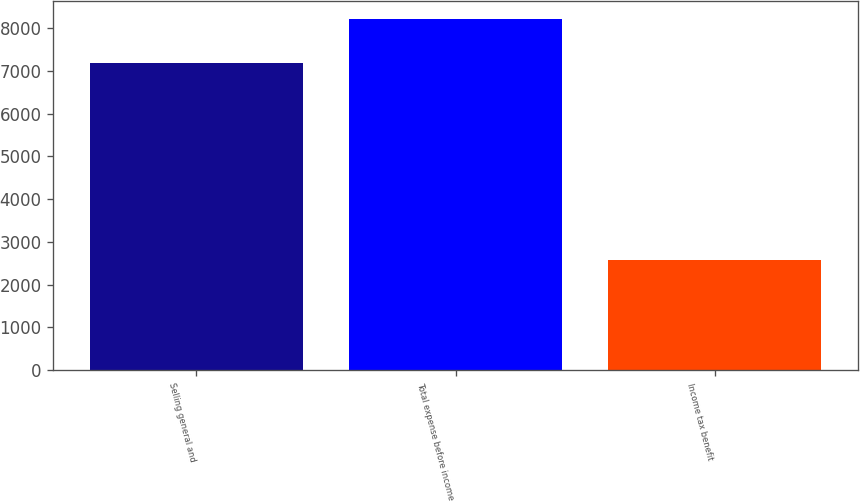<chart> <loc_0><loc_0><loc_500><loc_500><bar_chart><fcel>Selling general and<fcel>Total expense before income<fcel>Income tax benefit<nl><fcel>7175<fcel>8218<fcel>2585<nl></chart> 